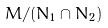Convert formula to latex. <formula><loc_0><loc_0><loc_500><loc_500>M / ( N _ { 1 } \cap N _ { 2 } )</formula> 